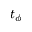Convert formula to latex. <formula><loc_0><loc_0><loc_500><loc_500>t _ { \phi }</formula> 